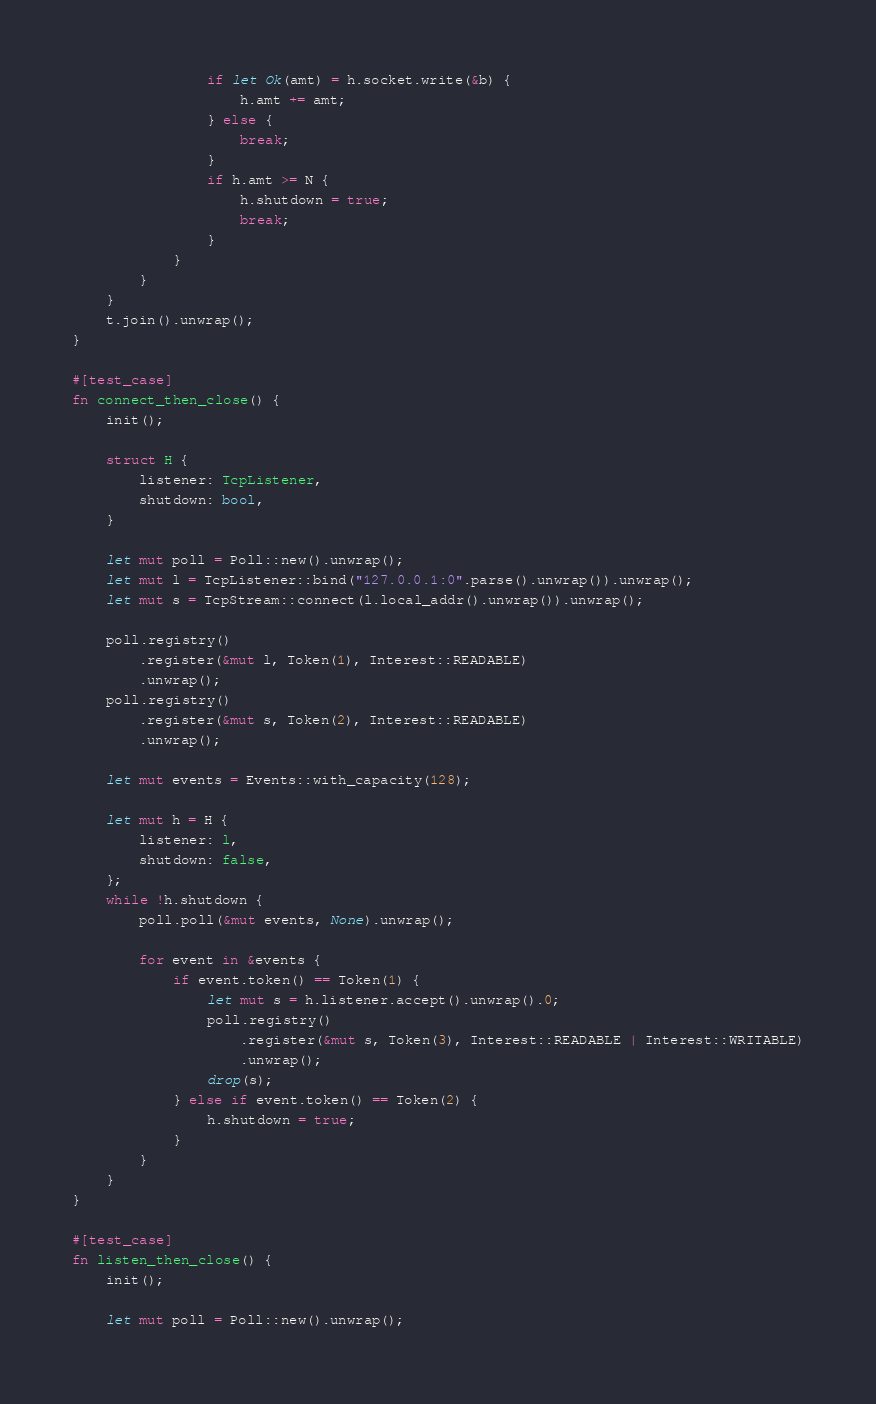<code> <loc_0><loc_0><loc_500><loc_500><_Rust_>                if let Ok(amt) = h.socket.write(&b) {
                    h.amt += amt;
                } else {
                    break;
                }
                if h.amt >= N {
                    h.shutdown = true;
                    break;
                }
            }
        }
    }
    t.join().unwrap();
}

#[test_case]
fn connect_then_close() {
    init();

    struct H {
        listener: TcpListener,
        shutdown: bool,
    }

    let mut poll = Poll::new().unwrap();
    let mut l = TcpListener::bind("127.0.0.1:0".parse().unwrap()).unwrap();
    let mut s = TcpStream::connect(l.local_addr().unwrap()).unwrap();

    poll.registry()
        .register(&mut l, Token(1), Interest::READABLE)
        .unwrap();
    poll.registry()
        .register(&mut s, Token(2), Interest::READABLE)
        .unwrap();

    let mut events = Events::with_capacity(128);

    let mut h = H {
        listener: l,
        shutdown: false,
    };
    while !h.shutdown {
        poll.poll(&mut events, None).unwrap();

        for event in &events {
            if event.token() == Token(1) {
                let mut s = h.listener.accept().unwrap().0;
                poll.registry()
                    .register(&mut s, Token(3), Interest::READABLE | Interest::WRITABLE)
                    .unwrap();
                drop(s);
            } else if event.token() == Token(2) {
                h.shutdown = true;
            }
        }
    }
}

#[test_case]
fn listen_then_close() {
    init();

    let mut poll = Poll::new().unwrap();</code> 